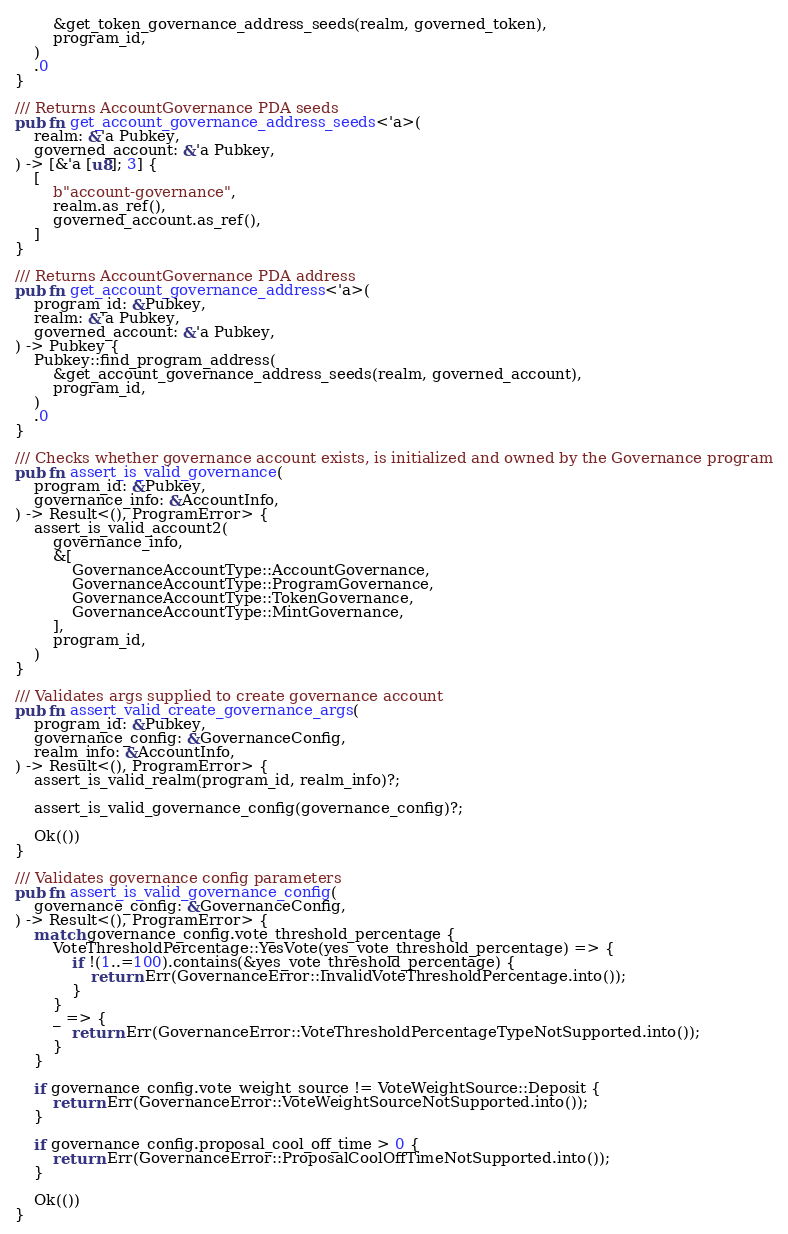Convert code to text. <code><loc_0><loc_0><loc_500><loc_500><_Rust_>        &get_token_governance_address_seeds(realm, governed_token),
        program_id,
    )
    .0
}

/// Returns AccountGovernance PDA seeds
pub fn get_account_governance_address_seeds<'a>(
    realm: &'a Pubkey,
    governed_account: &'a Pubkey,
) -> [&'a [u8]; 3] {
    [
        b"account-governance",
        realm.as_ref(),
        governed_account.as_ref(),
    ]
}

/// Returns AccountGovernance PDA address
pub fn get_account_governance_address<'a>(
    program_id: &Pubkey,
    realm: &'a Pubkey,
    governed_account: &'a Pubkey,
) -> Pubkey {
    Pubkey::find_program_address(
        &get_account_governance_address_seeds(realm, governed_account),
        program_id,
    )
    .0
}

/// Checks whether governance account exists, is initialized and owned by the Governance program
pub fn assert_is_valid_governance(
    program_id: &Pubkey,
    governance_info: &AccountInfo,
) -> Result<(), ProgramError> {
    assert_is_valid_account2(
        governance_info,
        &[
            GovernanceAccountType::AccountGovernance,
            GovernanceAccountType::ProgramGovernance,
            GovernanceAccountType::TokenGovernance,
            GovernanceAccountType::MintGovernance,
        ],
        program_id,
    )
}

/// Validates args supplied to create governance account
pub fn assert_valid_create_governance_args(
    program_id: &Pubkey,
    governance_config: &GovernanceConfig,
    realm_info: &AccountInfo,
) -> Result<(), ProgramError> {
    assert_is_valid_realm(program_id, realm_info)?;

    assert_is_valid_governance_config(governance_config)?;

    Ok(())
}

/// Validates governance config parameters
pub fn assert_is_valid_governance_config(
    governance_config: &GovernanceConfig,
) -> Result<(), ProgramError> {
    match governance_config.vote_threshold_percentage {
        VoteThresholdPercentage::YesVote(yes_vote_threshold_percentage) => {
            if !(1..=100).contains(&yes_vote_threshold_percentage) {
                return Err(GovernanceError::InvalidVoteThresholdPercentage.into());
            }
        }
        _ => {
            return Err(GovernanceError::VoteThresholdPercentageTypeNotSupported.into());
        }
    }

    if governance_config.vote_weight_source != VoteWeightSource::Deposit {
        return Err(GovernanceError::VoteWeightSourceNotSupported.into());
    }

    if governance_config.proposal_cool_off_time > 0 {
        return Err(GovernanceError::ProposalCoolOffTimeNotSupported.into());
    }

    Ok(())
}
</code> 